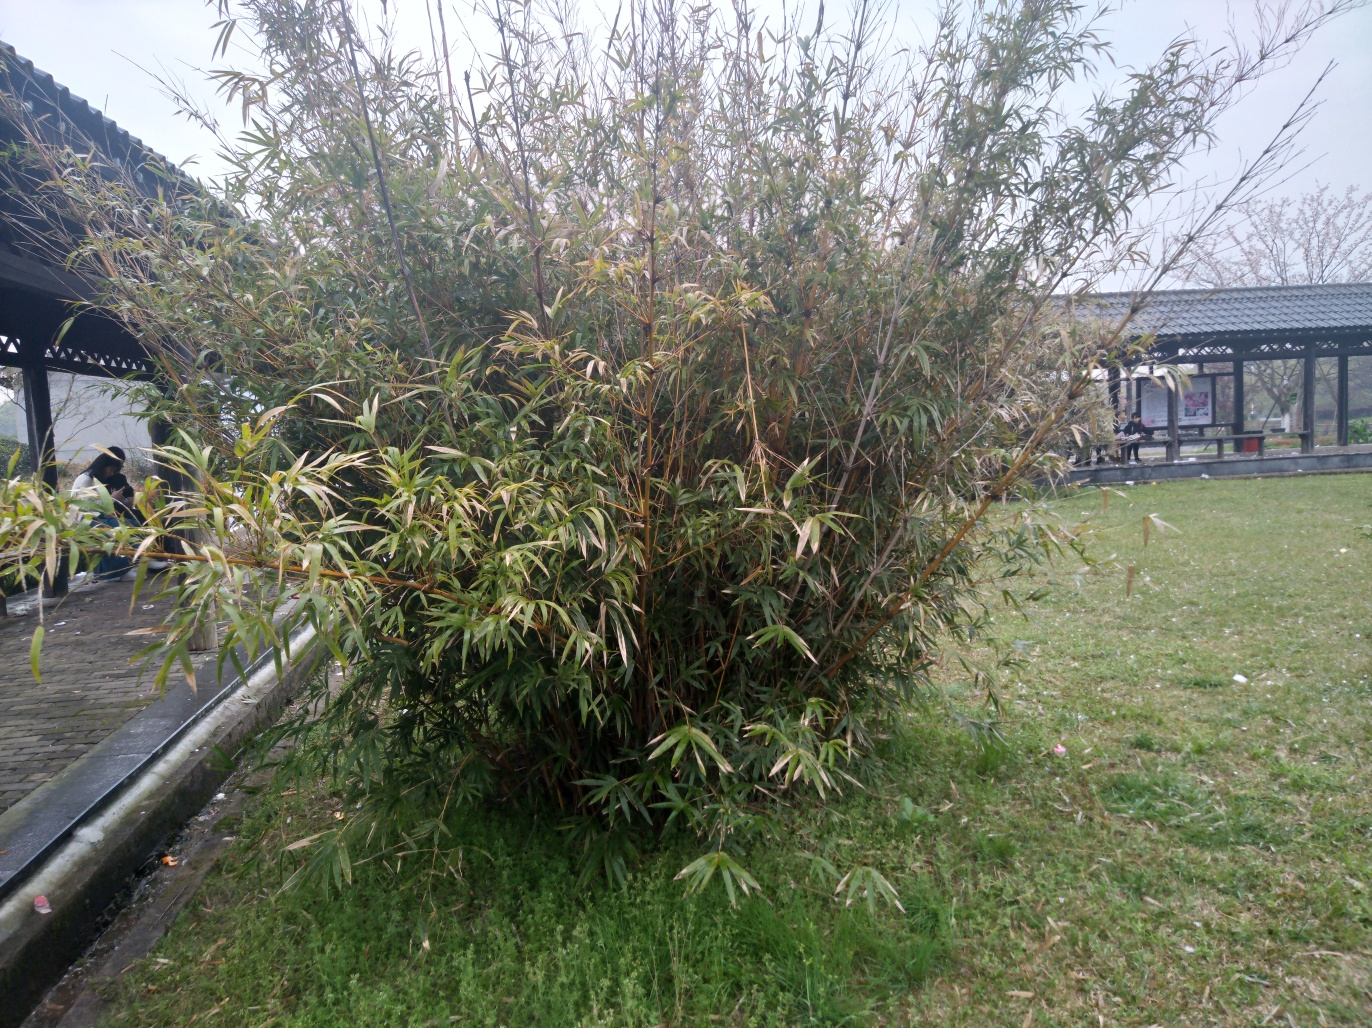What could be the weather or season when this photo was taken? The overcast sky and the moisture on the paved surface suggest that the weather could be humid or that it has recently rained. Given the lush green color of the grass and plants, it might be spring or summer, which are typically rainy seasons that contribute to the vibrancy of plant life. 